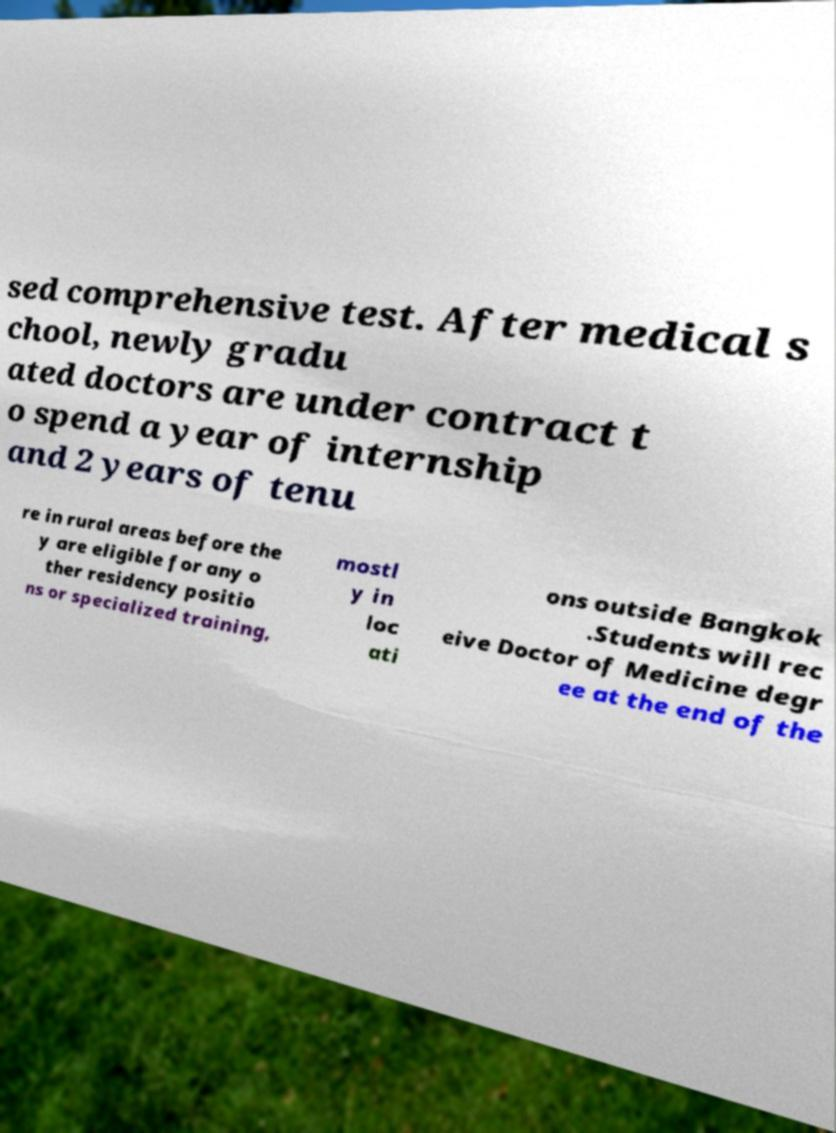What messages or text are displayed in this image? I need them in a readable, typed format. sed comprehensive test. After medical s chool, newly gradu ated doctors are under contract t o spend a year of internship and 2 years of tenu re in rural areas before the y are eligible for any o ther residency positio ns or specialized training, mostl y in loc ati ons outside Bangkok .Students will rec eive Doctor of Medicine degr ee at the end of the 